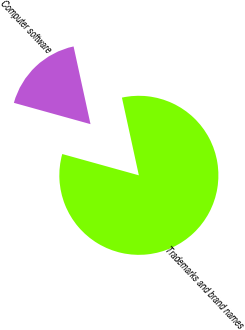<chart> <loc_0><loc_0><loc_500><loc_500><pie_chart><fcel>Trademarks and brand names<fcel>Computer software<nl><fcel>82.73%<fcel>17.27%<nl></chart> 